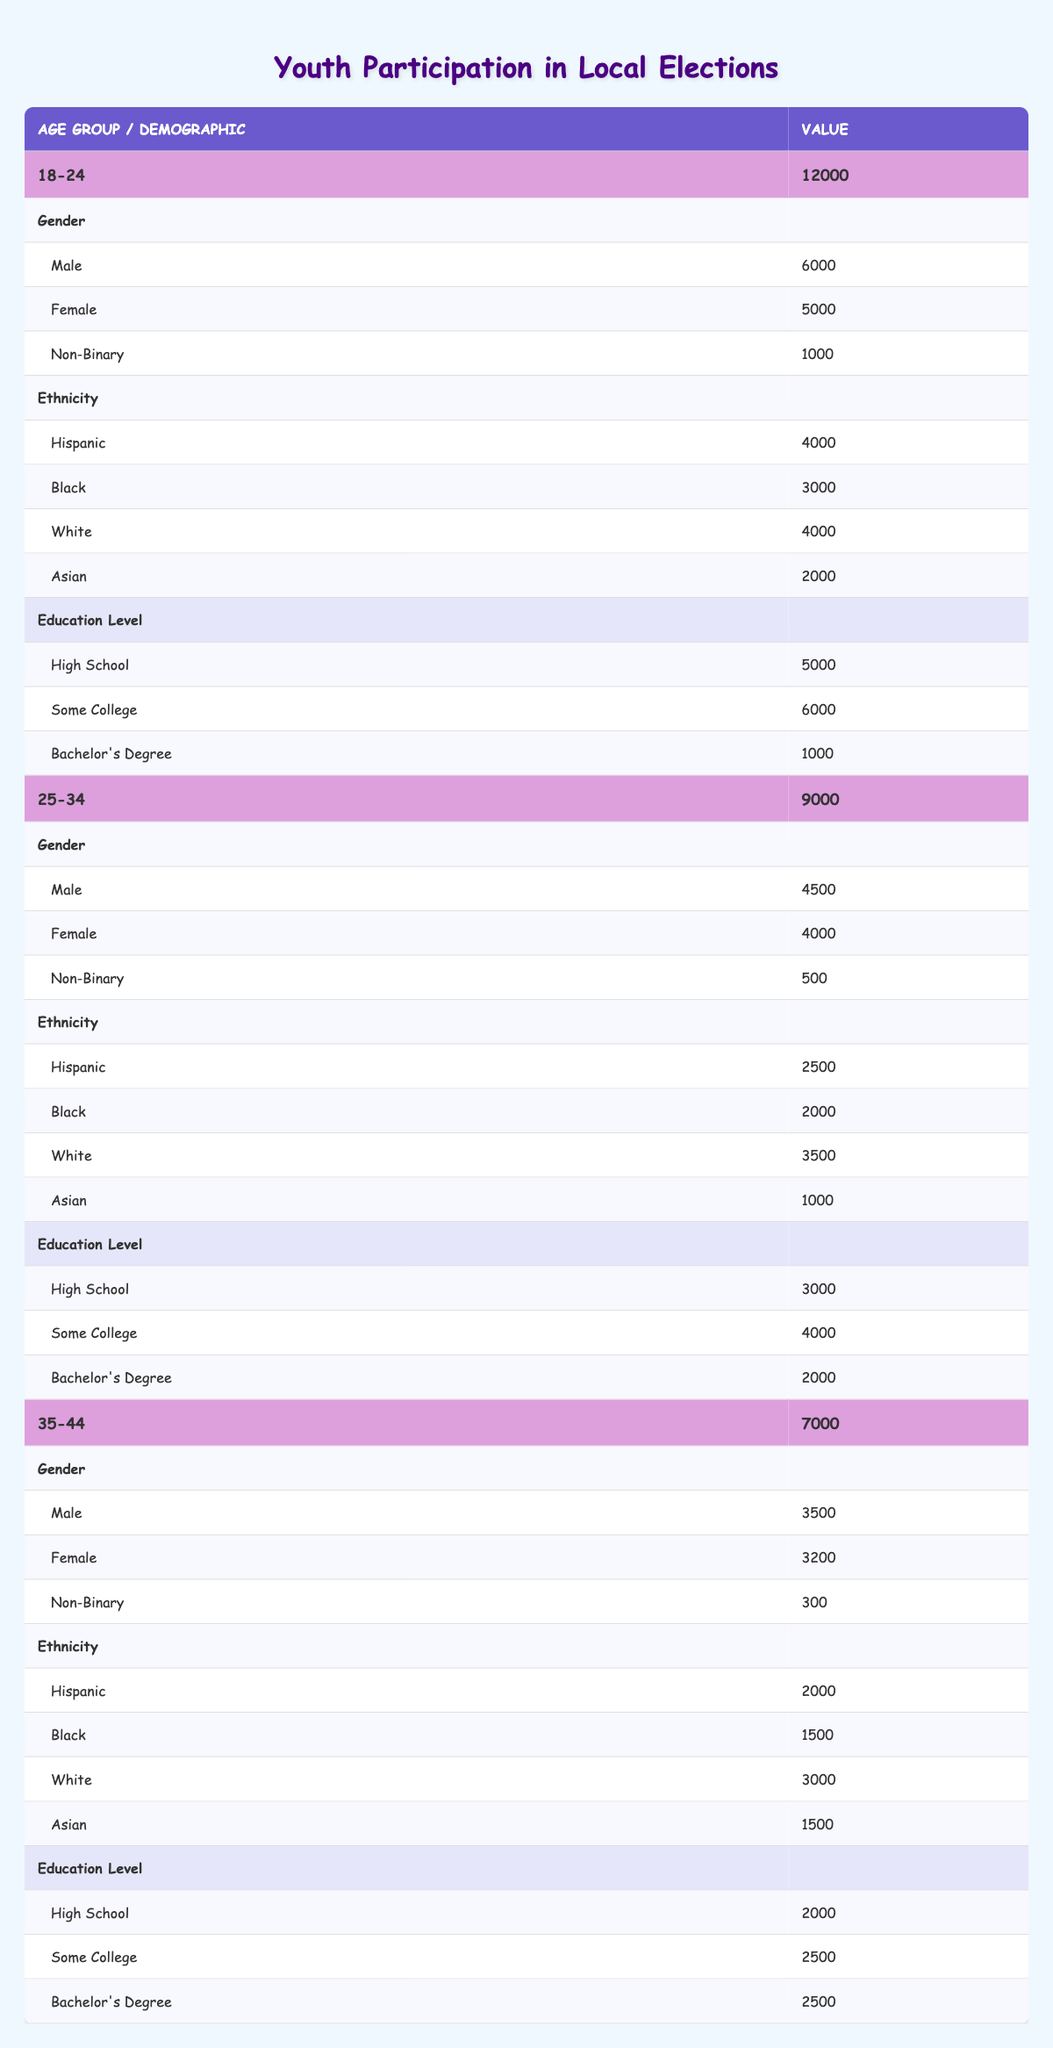What is the total number of voters in the 18-24 age group? The table shows that the total number of voters in the 18-24 age group is explicitly listed as 12000.
Answer: 12000 How many female voters are there in the 25-34 age group? In the table, the number of female voters in the 25-34 age group is directly stated as 4000.
Answer: 4000 What is the total number of voters aged 35-44? The table lists the total number of voters in the 35-44 age group as 7000.
Answer: 7000 Which age group has the highest number of Hispanic voters? By comparing the Hispanic voters in each age group, the 18-24 age group has 4000 Hispanic voters, while the 25-34 age group has 2500, and the 35-44 age group has 2000. Therefore, the 18-24 age group has the highest number.
Answer: 18-24 What percentage of the total voters in the 18-24 age group are Non-Binary? There are 1000 Non-Binary voters out of 12000 total voters in the 18-24 age group. To calculate the percentage, we use (1000/12000) * 100, which equals 8.33%.
Answer: 8.33% Are there more male voters in the 25-34 age group compared to the 35-44 age group? The table shows that there are 4500 male voters in the 25-34 age group and 3500 in the 35-44 age group. Since 4500 is greater than 3500, the statement is true.
Answer: Yes What is the combined total of Asian voters in the 25-34 and 35-44 age groups? In the 25-34 age group, there are 1000 Asian voters, and in the 35-44 age group, there are 1500. Adding these together (1000 + 1500) results in a total of 2500 Asian voters.
Answer: 2500 What is the difference in the number of White voters between the 18-24 and 25-34 age groups? From the table, the number of White voters in the 18-24 age group is 4000, and in the 25-34 age group, it is 3500. The difference is calculated as 4000 - 3500, which equals 500.
Answer: 500 Which demographic has the lowest number of voters in the 35-44 age group? Reviewing the demographics in the 35-44 age group, Non-Binary voters total 300, while the other categories (Male, Female, Hispanic, Black, White, and Asian) are all higher. Therefore, Non-Binary has the lowest number.
Answer: Non-Binary 